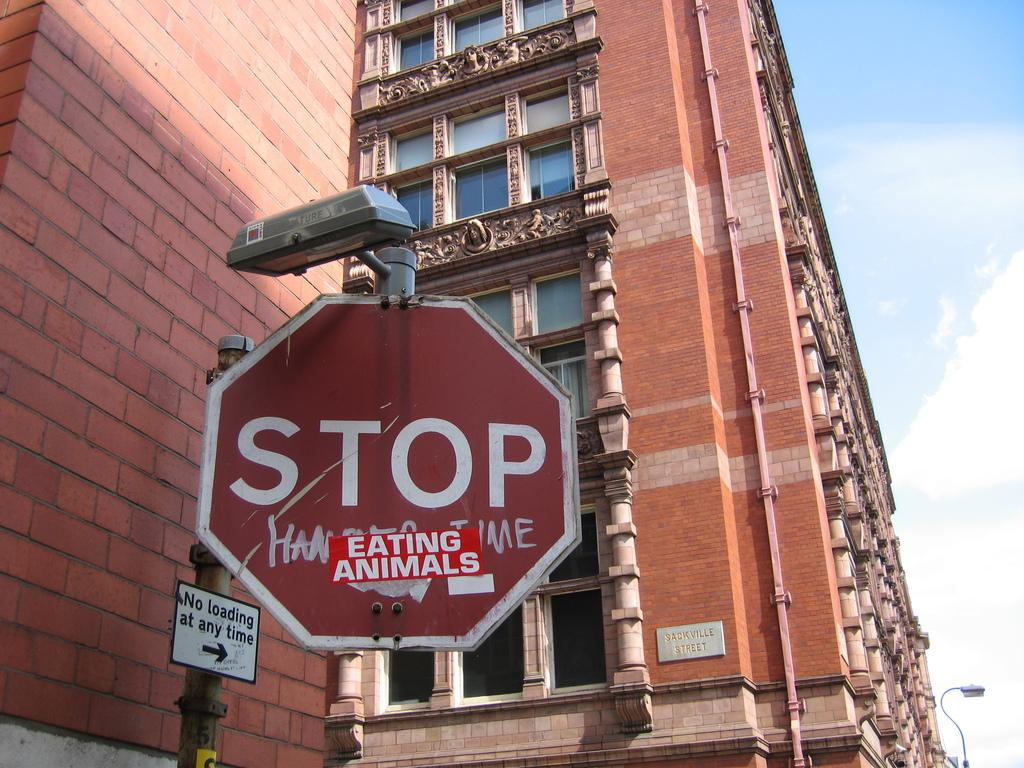<image>
Describe the image concisely. A stop sign under which someone has put a sticker reading 'eating animals' 